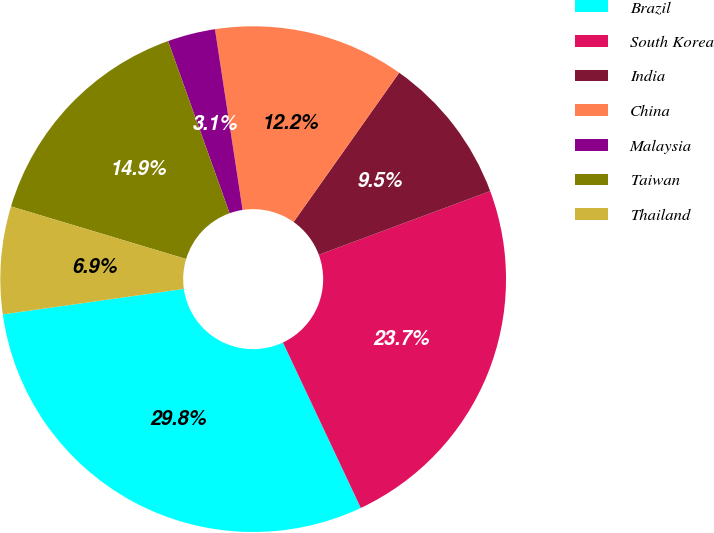<chart> <loc_0><loc_0><loc_500><loc_500><pie_chart><fcel>Brazil<fcel>South Korea<fcel>India<fcel>China<fcel>Malaysia<fcel>Taiwan<fcel>Thailand<nl><fcel>29.77%<fcel>23.66%<fcel>9.54%<fcel>12.21%<fcel>3.05%<fcel>14.89%<fcel>6.87%<nl></chart> 